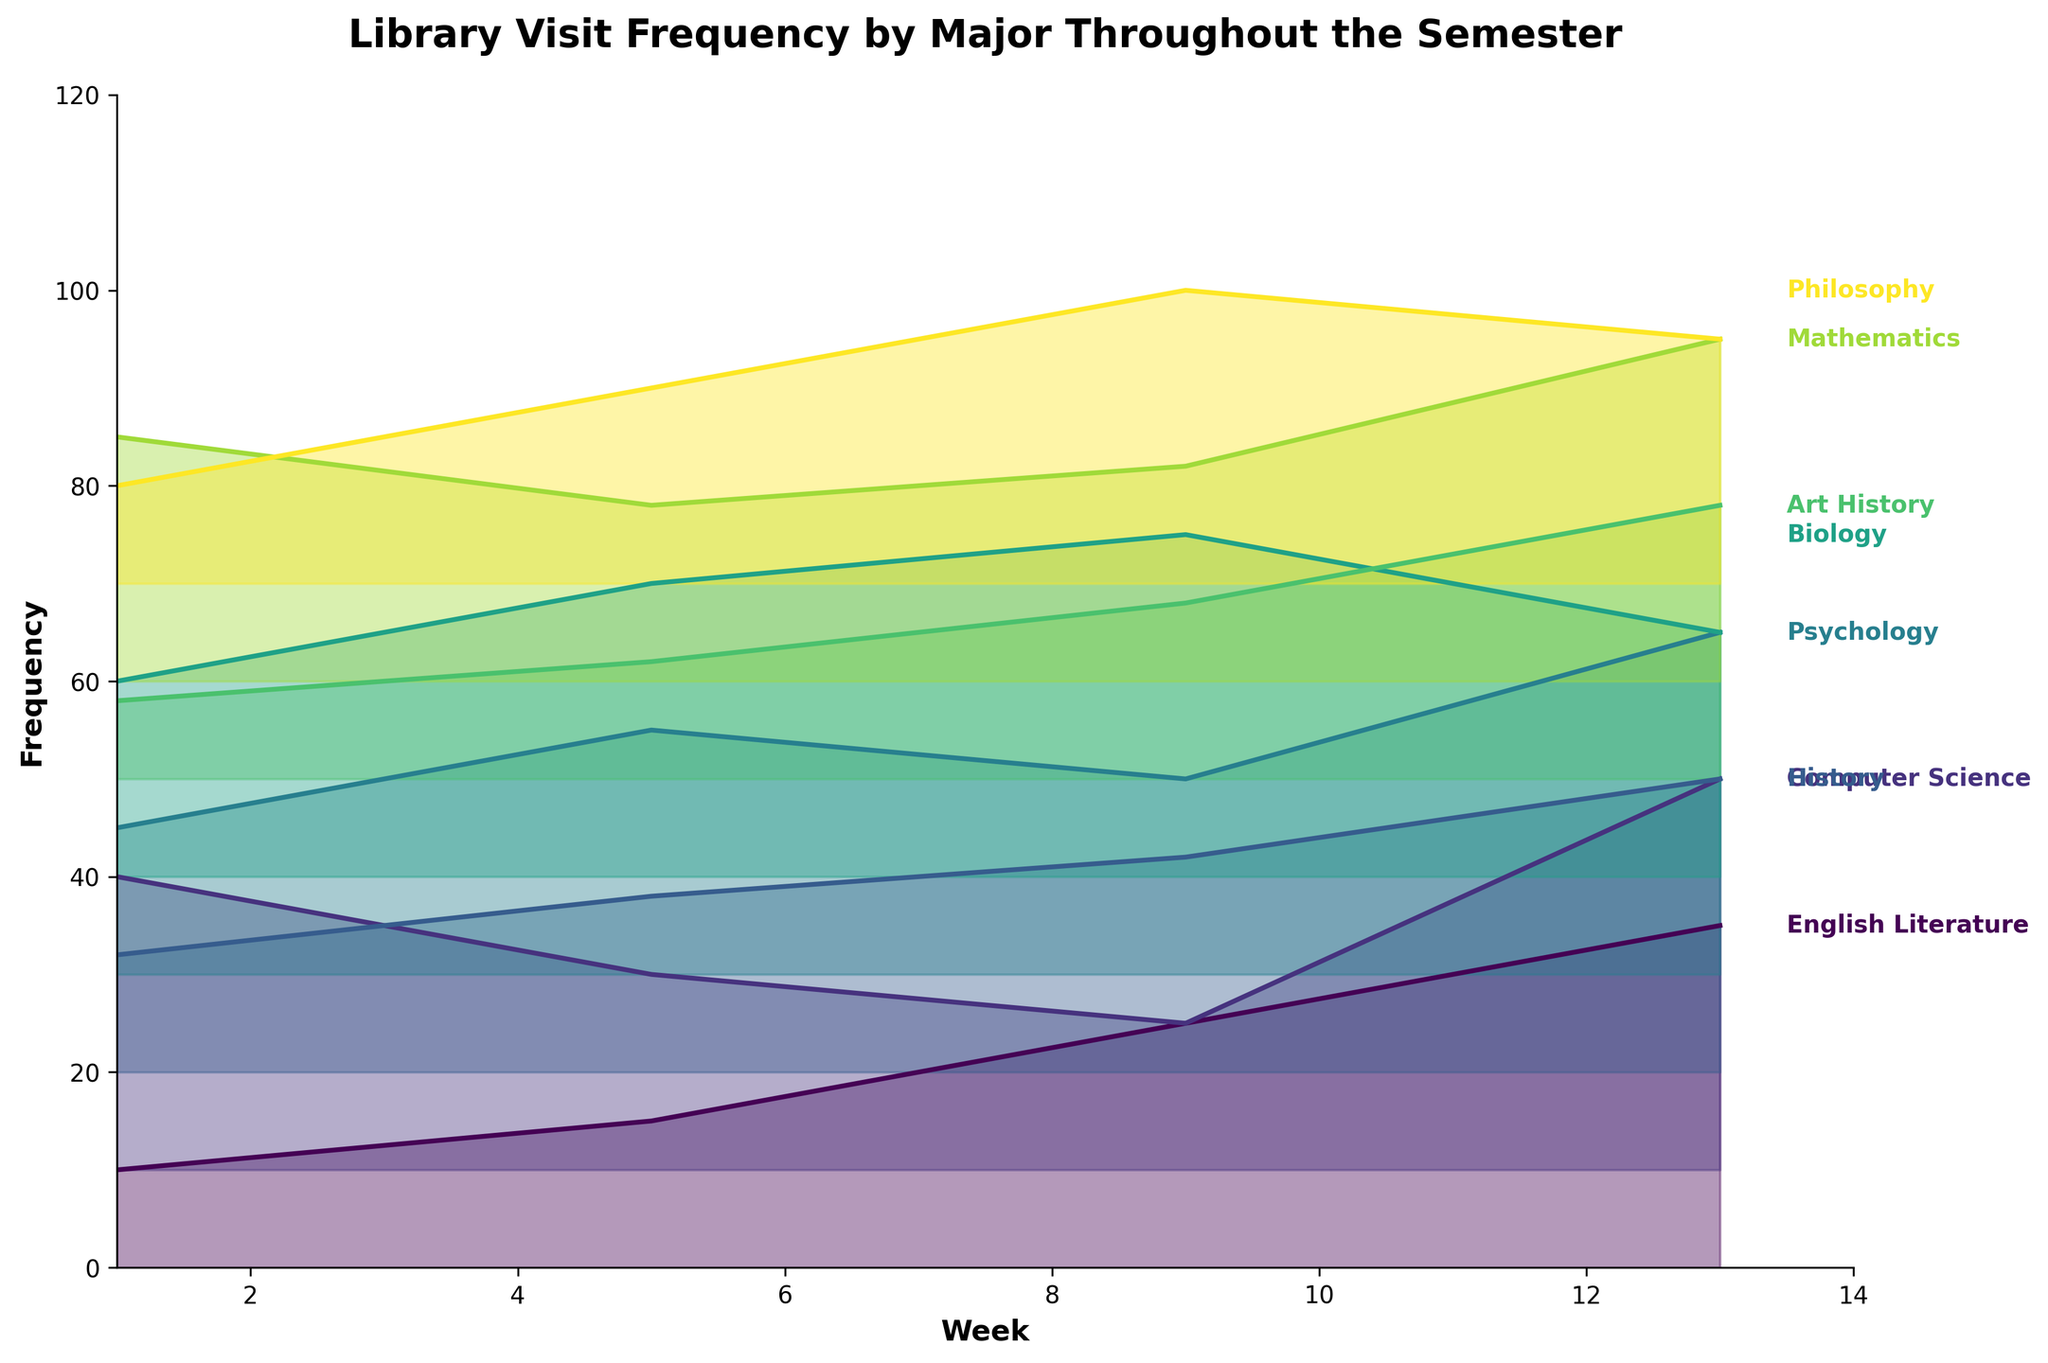How many majors are represented in the figure? To find the number of majors, we can count the different labeled lines in the ridgeline plot. Each major is labeled on the right side of its corresponding line.
Answer: 8 Which major had the highest library visit frequency in week 1? By examining the lines at week 1 and identifying the highest point, we can see which major it is associated with. The line for Computer Science is at the highest position at week 1.
Answer: Computer Science How many times did Biology students visit the library in week 9? To answer this, we locate the "Biology" line and follow it to week 9 to determine its value. The value at week 9 for Biology is 35.
Answer: 35 Between which weeks did Psychology students show a decrease in library visits? By tracing the "Psychology" line, we can note the points where the frequency decreases. The Psychology line decreases between weeks 5 and 9.
Answer: 5 and 9 Which majors had their peak library visits in week 13? To find this, we need to look at week 13 and identify the highest points for each line. The majors with peaks at week 13 are Computer Science, English Literature, Psychology, Mathematics, and Art History.
Answer: Computer Science, English Literature, Psychology, Mathematics, Art History What is the difference in library visit frequencies for English Literature between weeks 9 and 13? To find the difference, subtract the frequency at week 9 from the frequency at week 13 for English Literature. The calculation is 35 (week 13) - 25 (week 9) = 10.
Answer: 10 On average, how often did Philosophy students visit the library throughout the semester? To find the average, add the frequencies for each week, then divide by the number of weeks (4). The calculation is (10 + 20 + 30 + 25)/4 = 21.25.
Answer: 21.25 Which major had the most significant drop in library visits between any two weeks? By comparing the frequency drops for each major between consecutive weeks, we see that Biology students had the most significant drop from week 9 (35) to week 13 (25), which is a drop of 10 visits.
Answer: Biology What are the two weeks that Computer Science students showed an increase in library visits? By following the Computer Science line, we note where increases occur. The increases are from week 1 to week 13 (continuously), so the correct two weeks in sequence of increase could be 1 and 13.
Answer: 1 and 13 